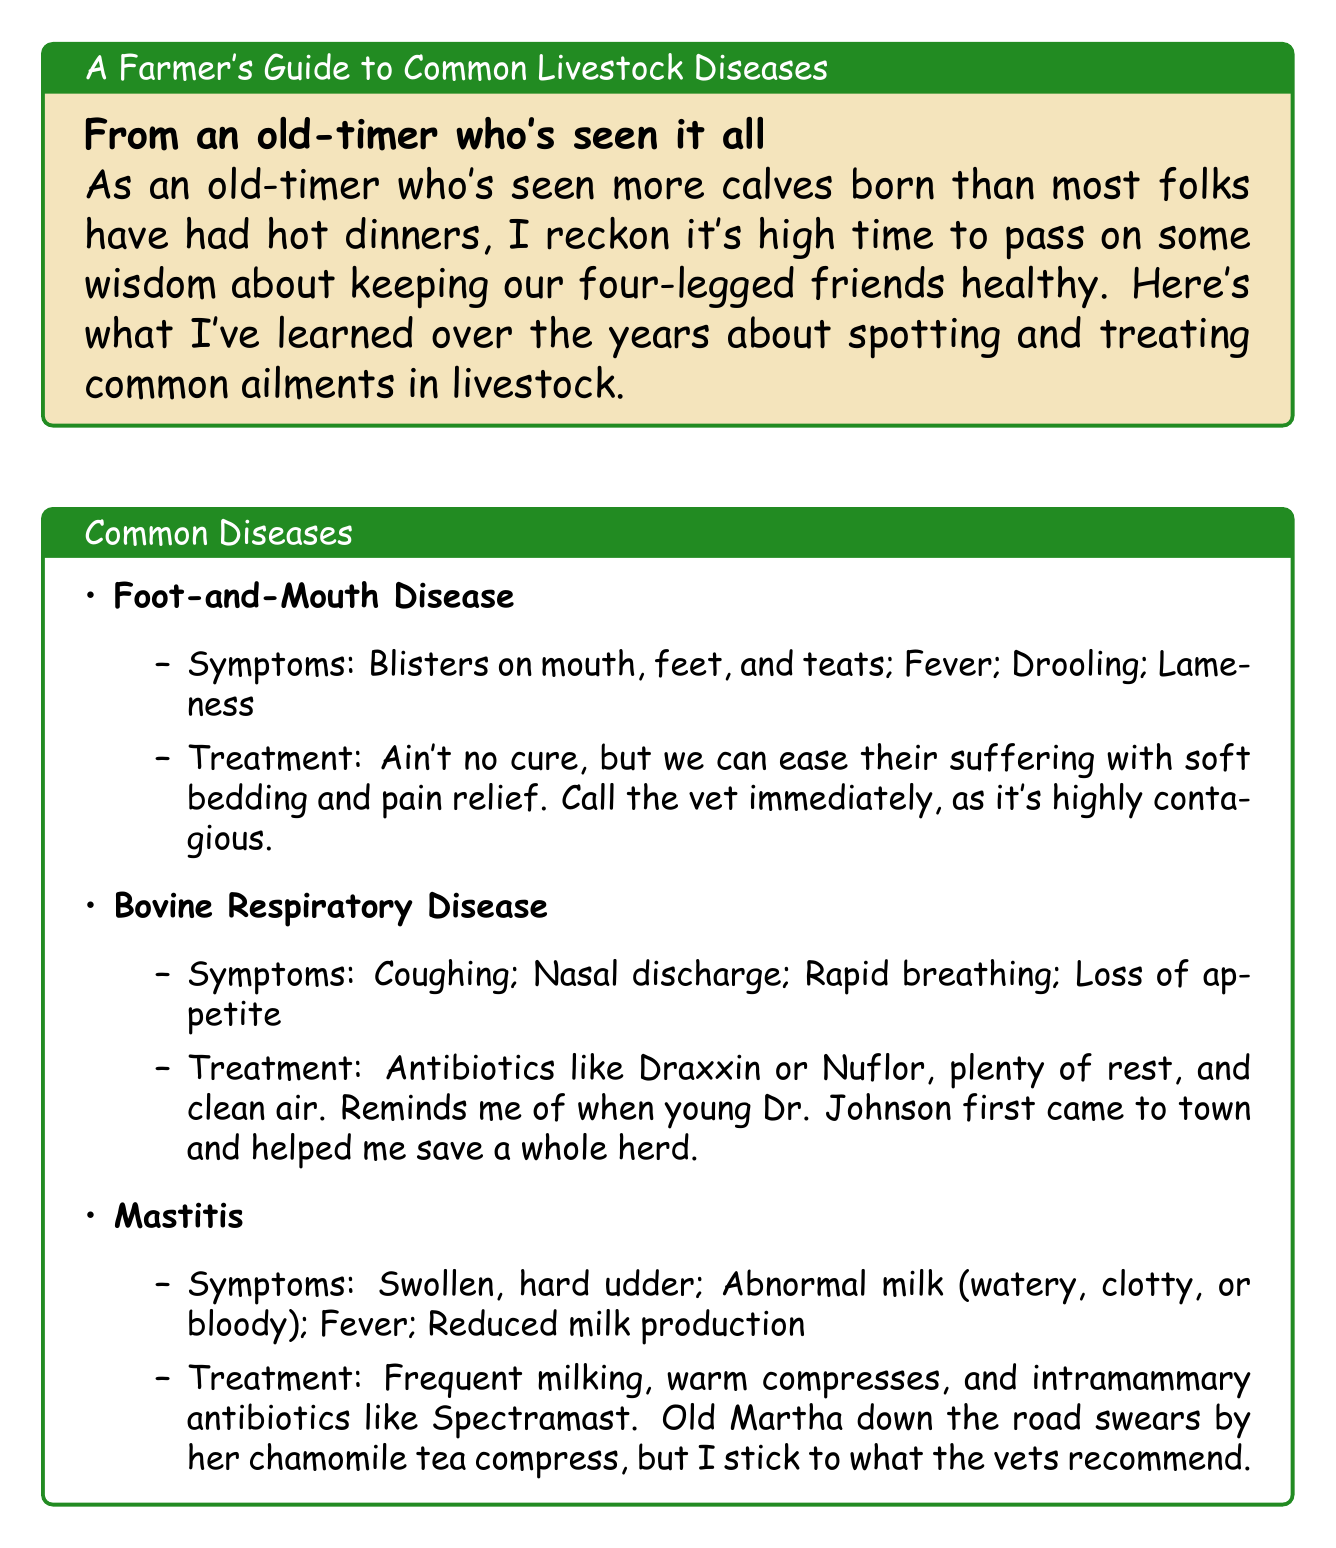what is the title of the document? The title is the main heading of the document, summarizing its content regarding common livestock diseases.
Answer: A Farmer's Guide to Common Livestock Diseases how many common diseases are identified in the document? The document outlines three specific diseases affecting livestock.
Answer: 3 what symptom is associated with Bovine Respiratory Disease? The question asks for an example of a symptom from the Bovine Respiratory Disease section of the document.
Answer: Coughing what treatment is recommended for Mastitis? The recommended treatment involves specific actions and medications detailed in the Mastitis section.
Answer: Frequent milking, warm compresses, and intramammary antibiotics like Spectramast what year did the farmer switch to a new feed mix? The farmer references a specific year related to improved cattle health due to a feed change.
Answer: 1982 what is the farmer's advice regarding new animals? This question addresses a preventative measure suggested by the farmer in the document.
Answer: Quarantine new animals who is mentioned as calling the vet for Foot-and-Mouth Disease? This question seeks to identify the general action regarding contact with a veterinarian for a specific disease.
Answer: Call the vet immediately what recurring event does the farmer emphasize with the vet? The farmer highlights an important routine concerning livestock health.
Answer: Regular check-ups with the vet 